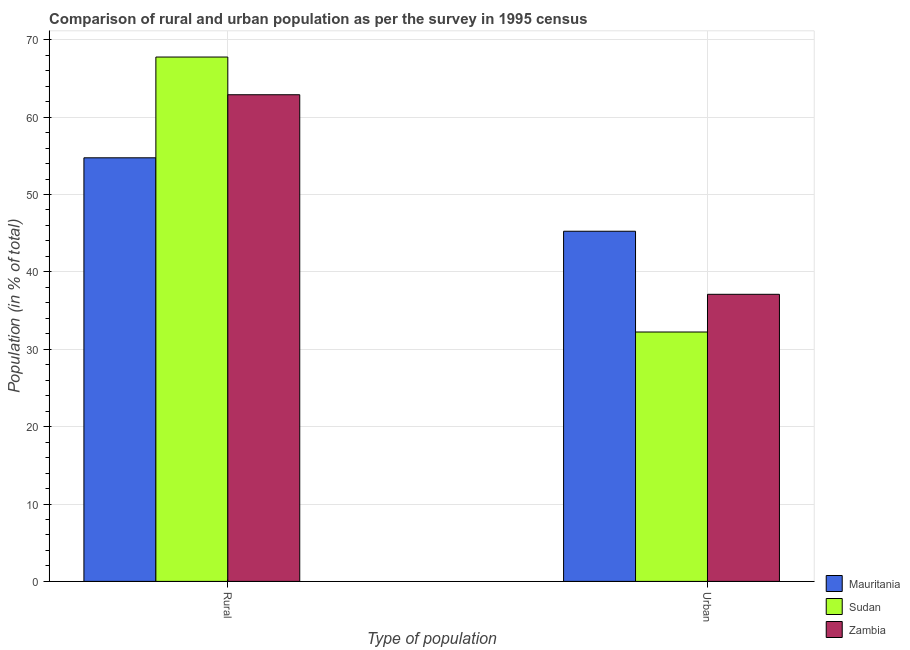How many groups of bars are there?
Keep it short and to the point. 2. Are the number of bars per tick equal to the number of legend labels?
Provide a succinct answer. Yes. Are the number of bars on each tick of the X-axis equal?
Make the answer very short. Yes. What is the label of the 1st group of bars from the left?
Give a very brief answer. Rural. What is the rural population in Zambia?
Your answer should be very brief. 62.9. Across all countries, what is the maximum urban population?
Your answer should be compact. 45.25. Across all countries, what is the minimum rural population?
Provide a short and direct response. 54.75. In which country was the urban population maximum?
Offer a terse response. Mauritania. In which country was the urban population minimum?
Ensure brevity in your answer.  Sudan. What is the total rural population in the graph?
Provide a short and direct response. 185.41. What is the difference between the urban population in Mauritania and that in Zambia?
Offer a terse response. 8.15. What is the difference between the urban population in Zambia and the rural population in Sudan?
Your response must be concise. -30.66. What is the average urban population per country?
Provide a succinct answer. 38.2. What is the difference between the rural population and urban population in Mauritania?
Keep it short and to the point. 9.49. In how many countries, is the urban population greater than 54 %?
Your response must be concise. 0. What is the ratio of the rural population in Mauritania to that in Zambia?
Your answer should be very brief. 0.87. What does the 1st bar from the left in Rural represents?
Keep it short and to the point. Mauritania. What does the 2nd bar from the right in Rural represents?
Your answer should be compact. Sudan. Are the values on the major ticks of Y-axis written in scientific E-notation?
Offer a very short reply. No. How are the legend labels stacked?
Offer a very short reply. Vertical. What is the title of the graph?
Keep it short and to the point. Comparison of rural and urban population as per the survey in 1995 census. What is the label or title of the X-axis?
Keep it short and to the point. Type of population. What is the label or title of the Y-axis?
Ensure brevity in your answer.  Population (in % of total). What is the Population (in % of total) in Mauritania in Rural?
Your response must be concise. 54.75. What is the Population (in % of total) of Sudan in Rural?
Offer a terse response. 67.77. What is the Population (in % of total) in Zambia in Rural?
Offer a terse response. 62.9. What is the Population (in % of total) in Mauritania in Urban?
Your response must be concise. 45.25. What is the Population (in % of total) in Sudan in Urban?
Provide a succinct answer. 32.23. What is the Population (in % of total) in Zambia in Urban?
Your answer should be compact. 37.1. Across all Type of population, what is the maximum Population (in % of total) in Mauritania?
Provide a short and direct response. 54.75. Across all Type of population, what is the maximum Population (in % of total) in Sudan?
Offer a terse response. 67.77. Across all Type of population, what is the maximum Population (in % of total) of Zambia?
Ensure brevity in your answer.  62.9. Across all Type of population, what is the minimum Population (in % of total) in Mauritania?
Provide a succinct answer. 45.25. Across all Type of population, what is the minimum Population (in % of total) of Sudan?
Your response must be concise. 32.23. Across all Type of population, what is the minimum Population (in % of total) in Zambia?
Give a very brief answer. 37.1. What is the total Population (in % of total) in Mauritania in the graph?
Make the answer very short. 100. What is the total Population (in % of total) of Sudan in the graph?
Your answer should be compact. 100. What is the total Population (in % of total) in Zambia in the graph?
Provide a succinct answer. 100. What is the difference between the Population (in % of total) in Mauritania in Rural and that in Urban?
Offer a terse response. 9.49. What is the difference between the Population (in % of total) in Sudan in Rural and that in Urban?
Provide a succinct answer. 35.54. What is the difference between the Population (in % of total) of Zambia in Rural and that in Urban?
Give a very brief answer. 25.79. What is the difference between the Population (in % of total) of Mauritania in Rural and the Population (in % of total) of Sudan in Urban?
Make the answer very short. 22.51. What is the difference between the Population (in % of total) in Mauritania in Rural and the Population (in % of total) in Zambia in Urban?
Ensure brevity in your answer.  17.64. What is the difference between the Population (in % of total) of Sudan in Rural and the Population (in % of total) of Zambia in Urban?
Ensure brevity in your answer.  30.66. What is the difference between the Population (in % of total) in Mauritania and Population (in % of total) in Sudan in Rural?
Your answer should be very brief. -13.02. What is the difference between the Population (in % of total) in Mauritania and Population (in % of total) in Zambia in Rural?
Provide a short and direct response. -8.15. What is the difference between the Population (in % of total) of Sudan and Population (in % of total) of Zambia in Rural?
Offer a terse response. 4.87. What is the difference between the Population (in % of total) of Mauritania and Population (in % of total) of Sudan in Urban?
Make the answer very short. 13.02. What is the difference between the Population (in % of total) of Mauritania and Population (in % of total) of Zambia in Urban?
Make the answer very short. 8.15. What is the difference between the Population (in % of total) of Sudan and Population (in % of total) of Zambia in Urban?
Offer a terse response. -4.87. What is the ratio of the Population (in % of total) of Mauritania in Rural to that in Urban?
Offer a very short reply. 1.21. What is the ratio of the Population (in % of total) of Sudan in Rural to that in Urban?
Provide a succinct answer. 2.1. What is the ratio of the Population (in % of total) of Zambia in Rural to that in Urban?
Ensure brevity in your answer.  1.7. What is the difference between the highest and the second highest Population (in % of total) of Mauritania?
Give a very brief answer. 9.49. What is the difference between the highest and the second highest Population (in % of total) of Sudan?
Keep it short and to the point. 35.54. What is the difference between the highest and the second highest Population (in % of total) in Zambia?
Make the answer very short. 25.79. What is the difference between the highest and the lowest Population (in % of total) in Mauritania?
Keep it short and to the point. 9.49. What is the difference between the highest and the lowest Population (in % of total) in Sudan?
Your answer should be very brief. 35.54. What is the difference between the highest and the lowest Population (in % of total) in Zambia?
Your answer should be compact. 25.79. 